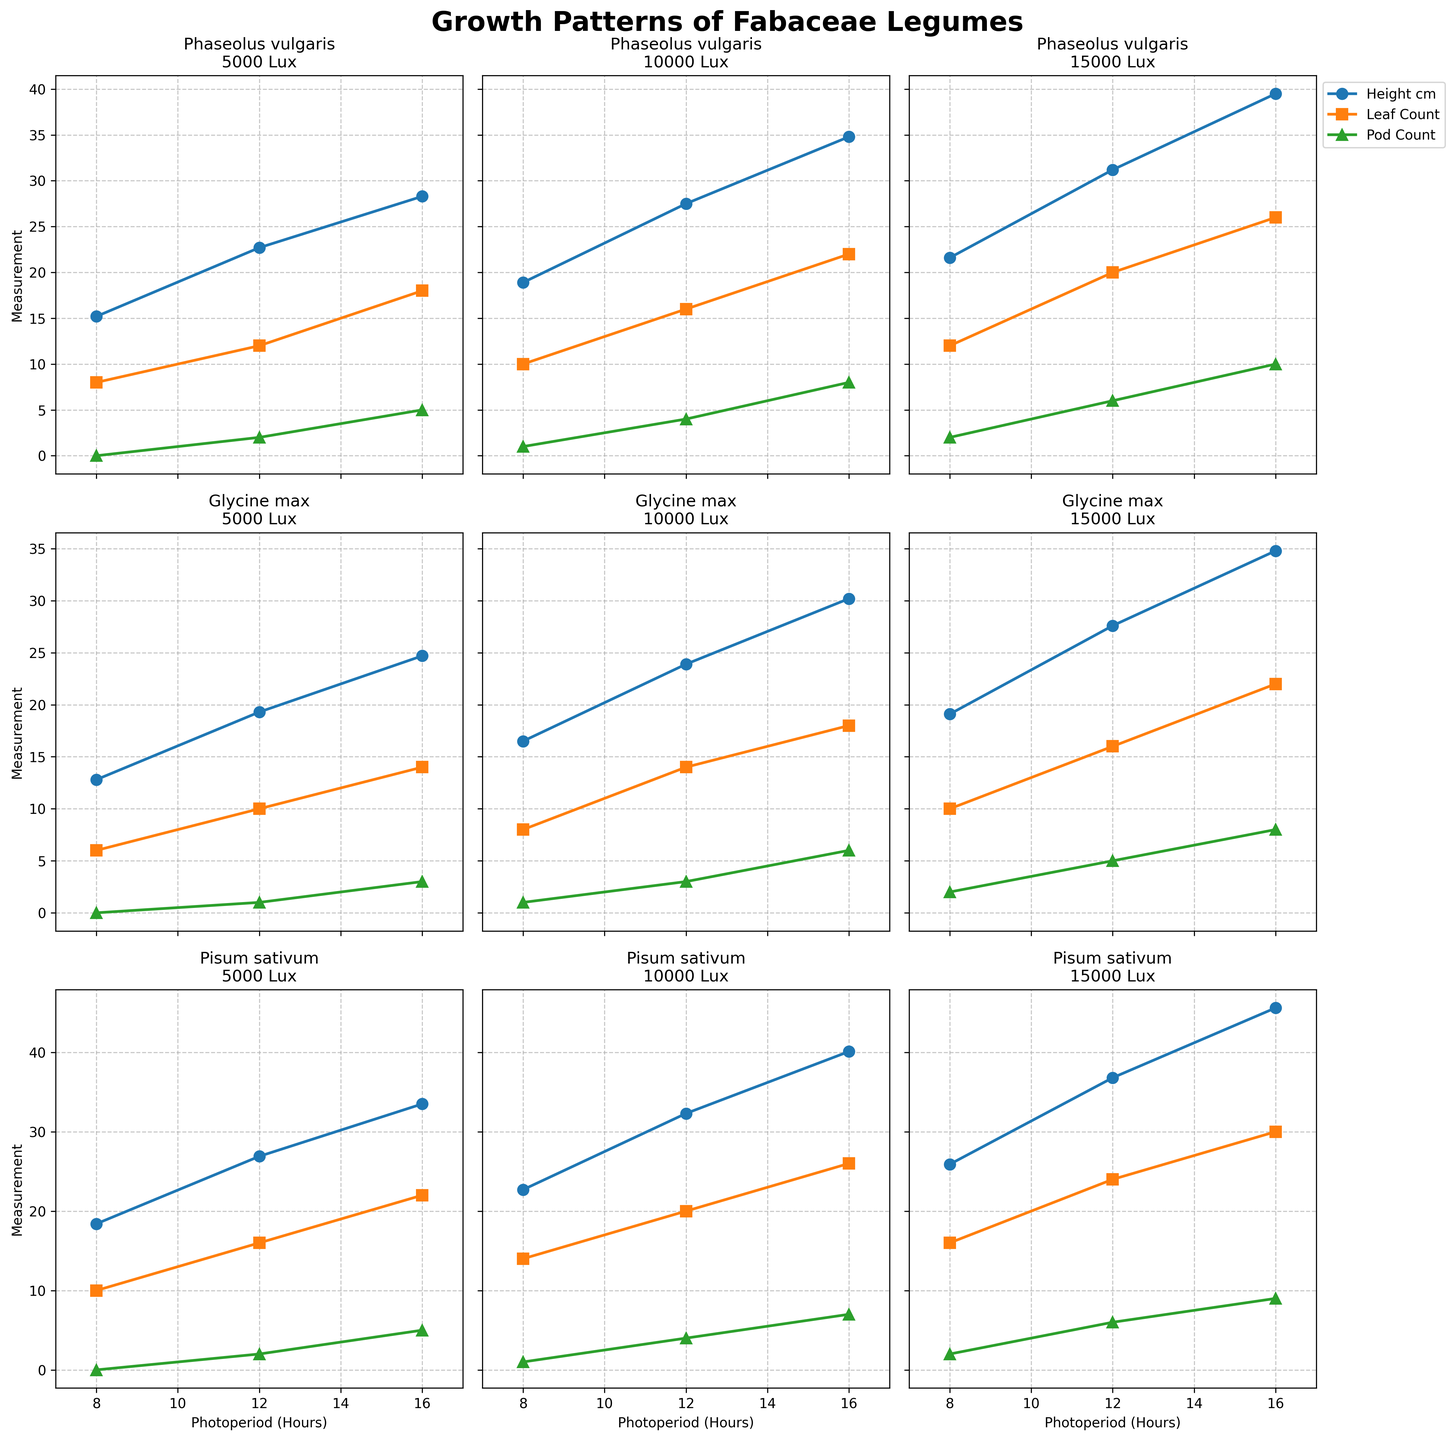What is the average leaf count for Glycine max under a light intensity of 10,000 Lux? The leaf counts for Glycine max under 10,000 Lux are 8, 14, and 18 for photoperiods of 8, 12, and 16 hours respectively. Summing these values gives 8 + 14 + 18 = 40. Dividing by the number of data points (3) gives 40 / 3 = 13.33
Answer: 13.33 Which species shows the highest height at 15,000 Lux and 16-hour photoperiod? By comparing the height values at 15,000 Lux and 16-hour photoperiod, Phaseolus vulgaris has 39.5 cm, Glycine max has 34.8 cm, and Pisum sativum has 45.6 cm. Therefore, Pisum sativum has the highest height.
Answer: Pisum sativum What is the height difference between Phaseolus vulgaris and Glycine max at a 12-hour photoperiod and 10,000 Lux? The height for Phaseolus vulgaris at 12-hour photoperiod and 10,000 Lux is 27.5 cm, and for Glycine max, it is 23.9 cm. The difference is 27.5 - 23.9 = 3.6 cm
Answer: 3.6 cm How many pods are produced by Pisum sativum at 5,000 Lux and a 16-hour photoperiod? By looking at the subplot for Pisum sativum under 5,000 Lux, the number of pods at a 16-hour photoperiod is 5.
Answer: 5 Among the three species under 5,000 Lux and a 12-hour photoperiod, which has the lowest leaf count? For the given conditions, Phaseolus vulgaris has 12 leaves, Glycine max has 10 leaves, and Pisum sativum has 16 leaves. Glycine max has the lowest leaf count.
Answer: Glycine max What is the visual trend of pod count for Phaseolus vulgaris as the photoperiod increases from 8 to 16 hours at 10,000 Lux? Observing the subplot for Phaseolus vulgaris under 10,000 Lux, pod count increases as the photoperiod increases: 1 pod at 8 hours, 4 pods at 12 hours, and 8 pods at 16 hours.
Answer: Increases What is the combined height of Glycine max at 8-hour and 16-hour photoperiods under 15,000 Lux? The height of Glycine max at an 8-hour photoperiod is 19.1 cm and at 16-hour photoperiod is 34.8 cm under 15,000 Lux. The combined height is 19.1 + 34.8 = 53.9 cm
Answer: 53.9 cm Comparing Phaseolus vulgaris and Pisum sativum, which species shows greater variation in height under 10,000 Lux? For Phaseolus vulgaris under 10,000 Lux: the heights are 18.9, 27.5, 34.8 (range: 34.8 - 18.9 = 15.9). For Pisum sativum under 10,000 Lux: heights are 22.7, 32.3, 40.1 (range: 40.1 - 22.7 = 17.4). Pisum sativum shows a greater variation.
Answer: Pisum sativum What is the trend in leaf count for Pisum sativum under increasing light intensity at a 12-hour photoperiod? Observing the subplot for Pisum sativum at a 12-hour photoperiod: under 5,000 Lux, there are 16 leaves; under 10,000 Lux, 20 leaves; under 15,000 Lux, 24 leaves. Leaf count increases with light intensity.
Answer: Increases For Phaseolus vulgaris, how does the pod count change from an 8-hour to a 12-hour photoperiod under 5,000 Lux? The subplot for Phaseolus vulgaris under 5,000 Lux shows the following: pod count at 8-hour photoperiod is 0 and at 12-hour photoperiod is 2. The pod count increases by 2 - 0 = 2.
Answer: Increases by 2 